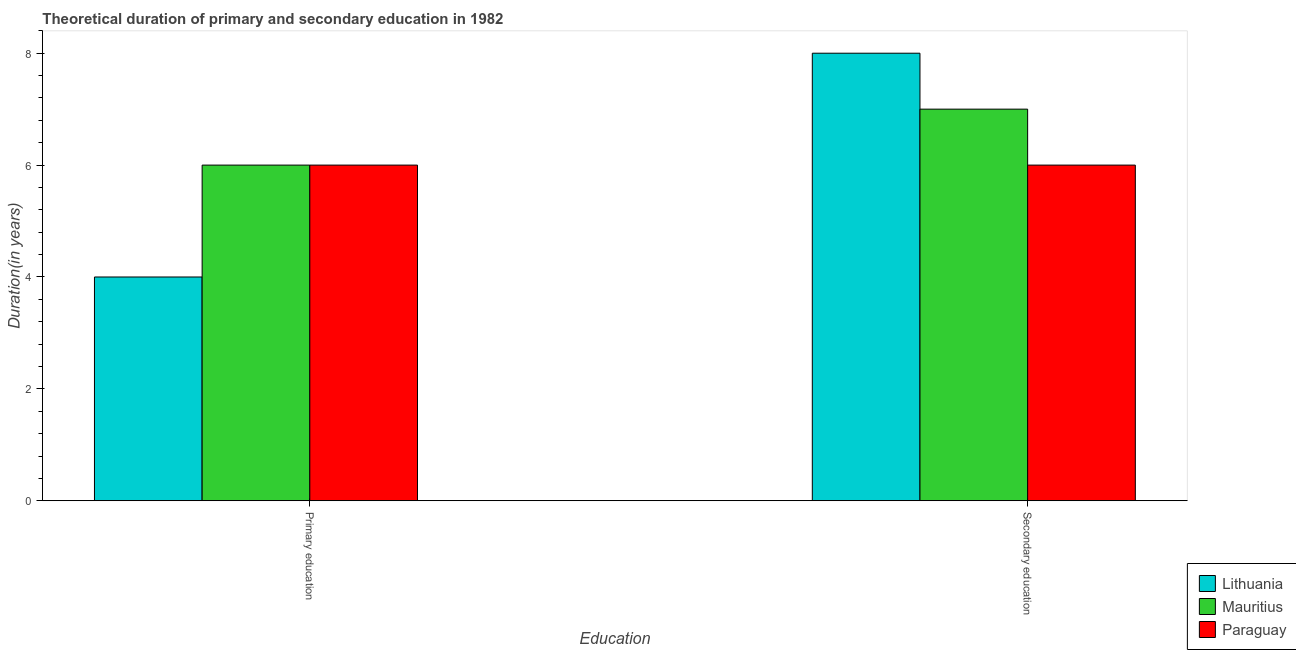Are the number of bars per tick equal to the number of legend labels?
Your answer should be compact. Yes. Are the number of bars on each tick of the X-axis equal?
Your response must be concise. Yes. What is the label of the 2nd group of bars from the left?
Your answer should be very brief. Secondary education. What is the duration of secondary education in Mauritius?
Your response must be concise. 7. Across all countries, what is the maximum duration of primary education?
Your answer should be very brief. 6. Across all countries, what is the minimum duration of secondary education?
Offer a terse response. 6. In which country was the duration of primary education maximum?
Offer a terse response. Mauritius. In which country was the duration of primary education minimum?
Make the answer very short. Lithuania. What is the total duration of secondary education in the graph?
Keep it short and to the point. 21. What is the difference between the duration of secondary education in Paraguay and that in Mauritius?
Your answer should be compact. -1. What is the difference between the duration of secondary education in Mauritius and the duration of primary education in Paraguay?
Ensure brevity in your answer.  1. What is the average duration of primary education per country?
Offer a terse response. 5.33. What is the difference between the duration of secondary education and duration of primary education in Paraguay?
Your response must be concise. 0. Is the duration of secondary education in Mauritius less than that in Paraguay?
Ensure brevity in your answer.  No. In how many countries, is the duration of primary education greater than the average duration of primary education taken over all countries?
Make the answer very short. 2. What does the 3rd bar from the left in Primary education represents?
Give a very brief answer. Paraguay. What does the 2nd bar from the right in Primary education represents?
Keep it short and to the point. Mauritius. How many bars are there?
Offer a terse response. 6. How many countries are there in the graph?
Keep it short and to the point. 3. Are the values on the major ticks of Y-axis written in scientific E-notation?
Ensure brevity in your answer.  No. What is the title of the graph?
Your response must be concise. Theoretical duration of primary and secondary education in 1982. Does "High income: nonOECD" appear as one of the legend labels in the graph?
Offer a very short reply. No. What is the label or title of the X-axis?
Provide a short and direct response. Education. What is the label or title of the Y-axis?
Your answer should be compact. Duration(in years). What is the Duration(in years) of Lithuania in Primary education?
Ensure brevity in your answer.  4. What is the Duration(in years) in Mauritius in Primary education?
Give a very brief answer. 6. Across all Education, what is the maximum Duration(in years) of Lithuania?
Keep it short and to the point. 8. Across all Education, what is the maximum Duration(in years) in Mauritius?
Your response must be concise. 7. Across all Education, what is the minimum Duration(in years) of Lithuania?
Give a very brief answer. 4. Across all Education, what is the minimum Duration(in years) in Mauritius?
Your answer should be compact. 6. What is the total Duration(in years) of Lithuania in the graph?
Your response must be concise. 12. What is the difference between the Duration(in years) in Paraguay in Primary education and that in Secondary education?
Keep it short and to the point. 0. What is the difference between the Duration(in years) in Lithuania in Primary education and the Duration(in years) in Paraguay in Secondary education?
Your response must be concise. -2. What is the average Duration(in years) in Lithuania per Education?
Offer a terse response. 6. What is the average Duration(in years) in Mauritius per Education?
Offer a terse response. 6.5. What is the difference between the Duration(in years) in Lithuania and Duration(in years) in Paraguay in Primary education?
Offer a terse response. -2. What is the difference between the Duration(in years) in Mauritius and Duration(in years) in Paraguay in Primary education?
Provide a succinct answer. 0. What is the ratio of the Duration(in years) in Lithuania in Primary education to that in Secondary education?
Give a very brief answer. 0.5. What is the ratio of the Duration(in years) in Mauritius in Primary education to that in Secondary education?
Give a very brief answer. 0.86. What is the difference between the highest and the second highest Duration(in years) in Lithuania?
Offer a very short reply. 4. What is the difference between the highest and the lowest Duration(in years) of Lithuania?
Your answer should be compact. 4. What is the difference between the highest and the lowest Duration(in years) of Paraguay?
Provide a succinct answer. 0. 